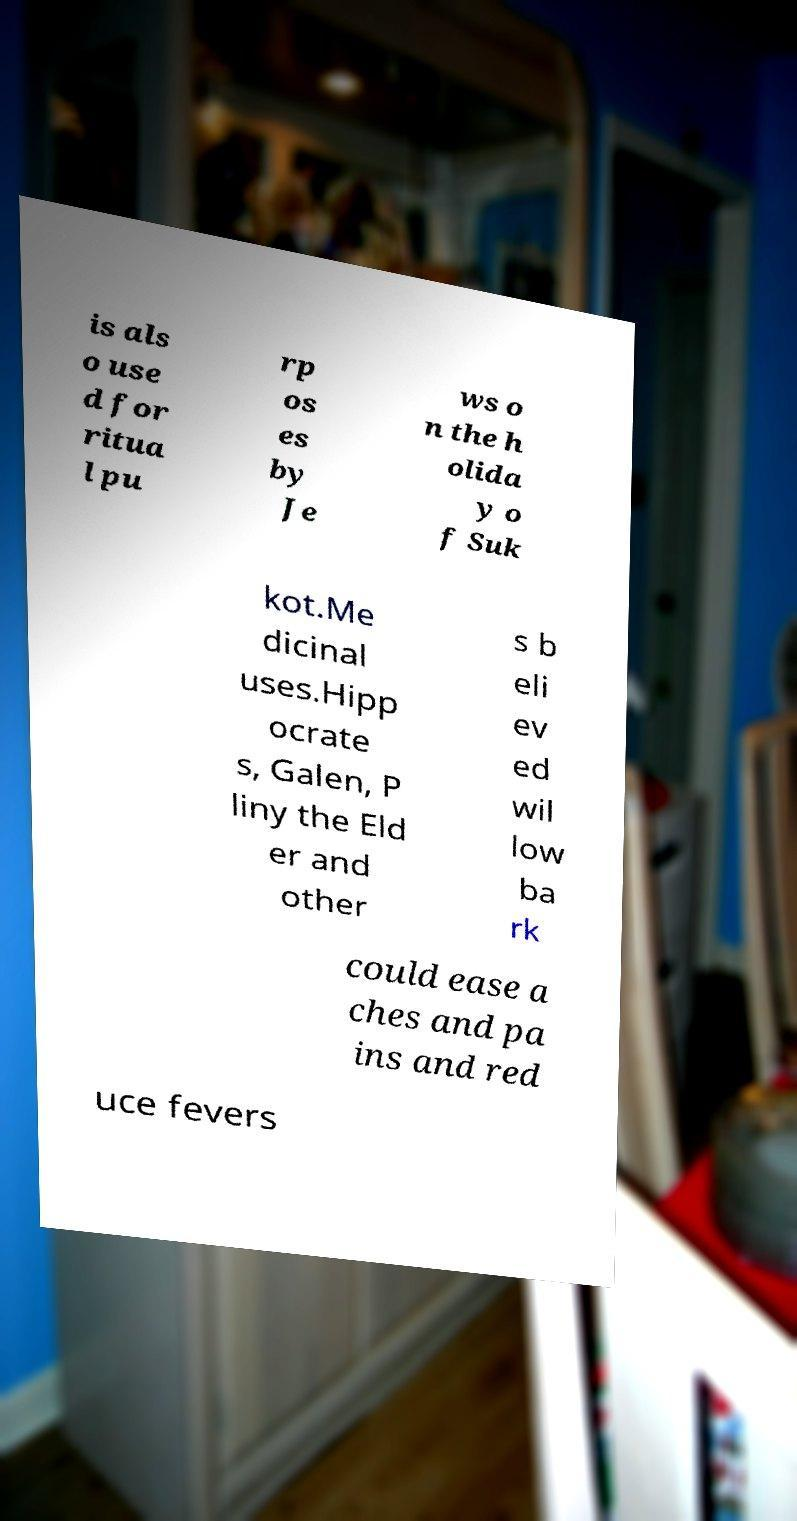Please identify and transcribe the text found in this image. is als o use d for ritua l pu rp os es by Je ws o n the h olida y o f Suk kot.Me dicinal uses.Hipp ocrate s, Galen, P liny the Eld er and other s b eli ev ed wil low ba rk could ease a ches and pa ins and red uce fevers 